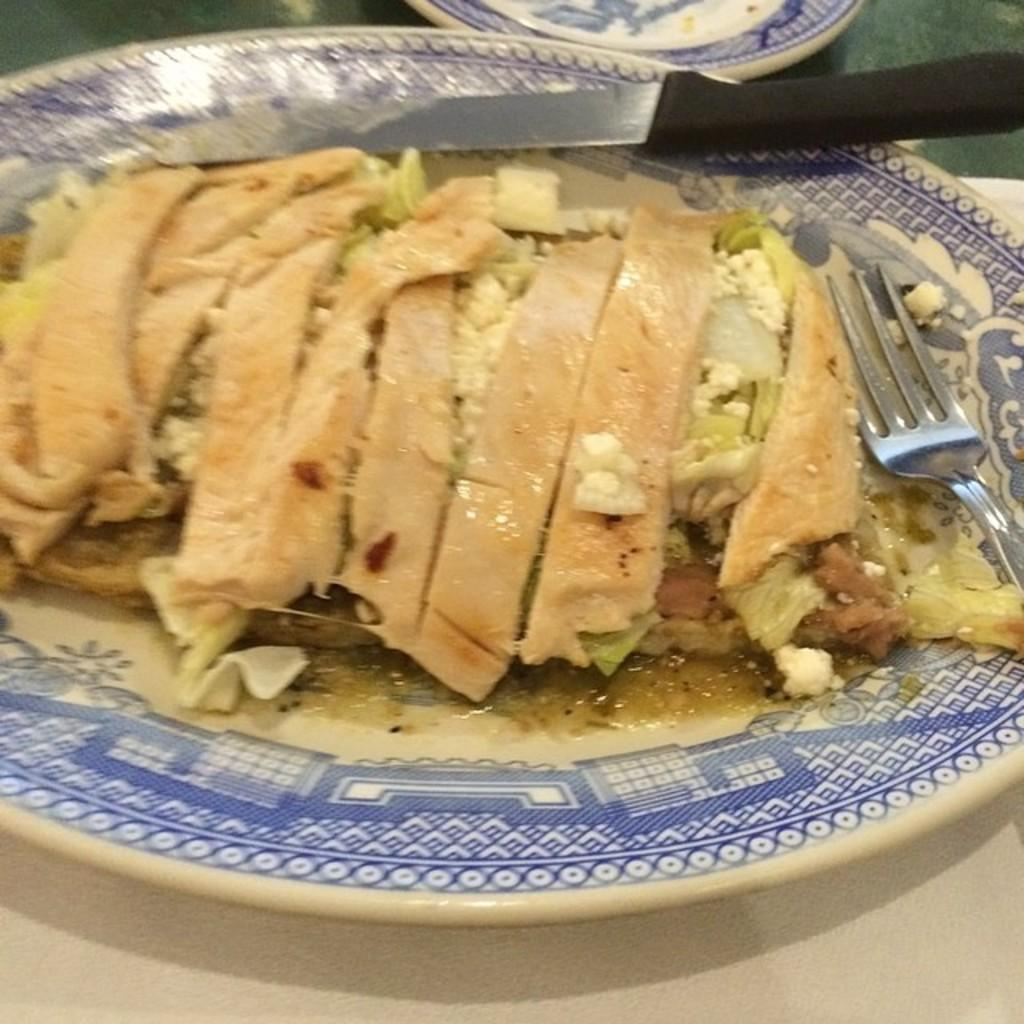What is on the plate that is visible in the image? There is a plate with food items in the image. What utensils are on the plate? There is a knife and fork on the plate. Where is the plate located? The plate is on a platform. Can you describe the background of the image? There is a plate in the background on a platform. What type of ornament is hanging from the plate in the image? There is no ornament hanging from the plate in the image; it only contains food items and utensils. 